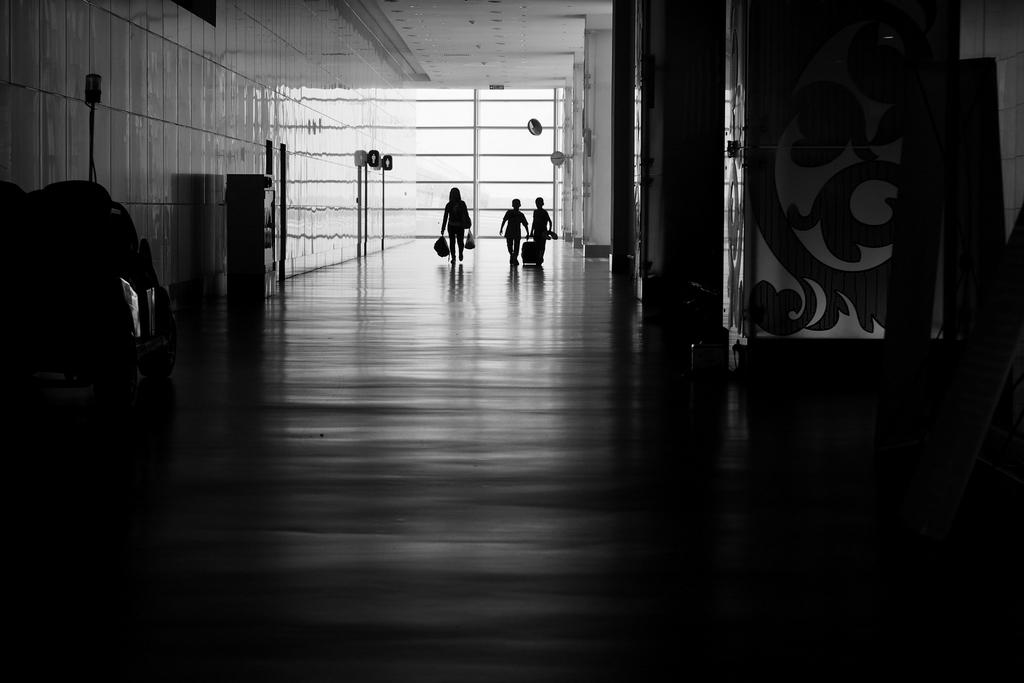How many people are in the image? There are three persons in the image. What are the people holding in their hands? Each person is holding an object in their hands. Can you describe the objects in the corners of the image? There is an object in the right corner and another in the left corner of the image. What type of juice is being served by the man in the image? There is no man present in the image, nor is there any juice being served. 